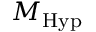Convert formula to latex. <formula><loc_0><loc_0><loc_500><loc_500>M _ { H y p }</formula> 